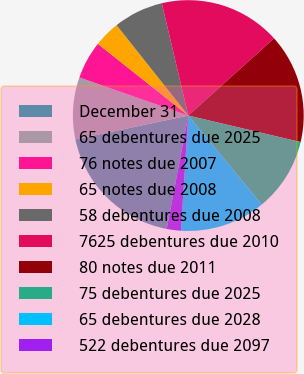Convert chart to OTSL. <chart><loc_0><loc_0><loc_500><loc_500><pie_chart><fcel>December 31<fcel>65 debentures due 2025<fcel>76 notes due 2007<fcel>65 notes due 2008<fcel>58 debentures due 2008<fcel>7625 debentures due 2010<fcel>80 notes due 2011<fcel>75 debentures due 2025<fcel>65 debentures due 2028<fcel>522 debentures due 2097<nl><fcel>18.69%<fcel>8.66%<fcel>5.32%<fcel>3.65%<fcel>6.99%<fcel>17.02%<fcel>15.35%<fcel>10.33%<fcel>12.0%<fcel>1.98%<nl></chart> 